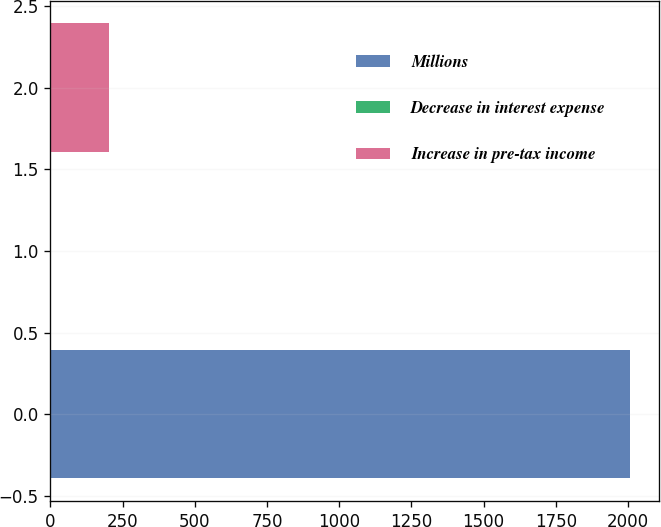Convert chart to OTSL. <chart><loc_0><loc_0><loc_500><loc_500><bar_chart><fcel>Millions<fcel>Decrease in interest expense<fcel>Increase in pre-tax income<nl><fcel>2008<fcel>1<fcel>201.7<nl></chart> 